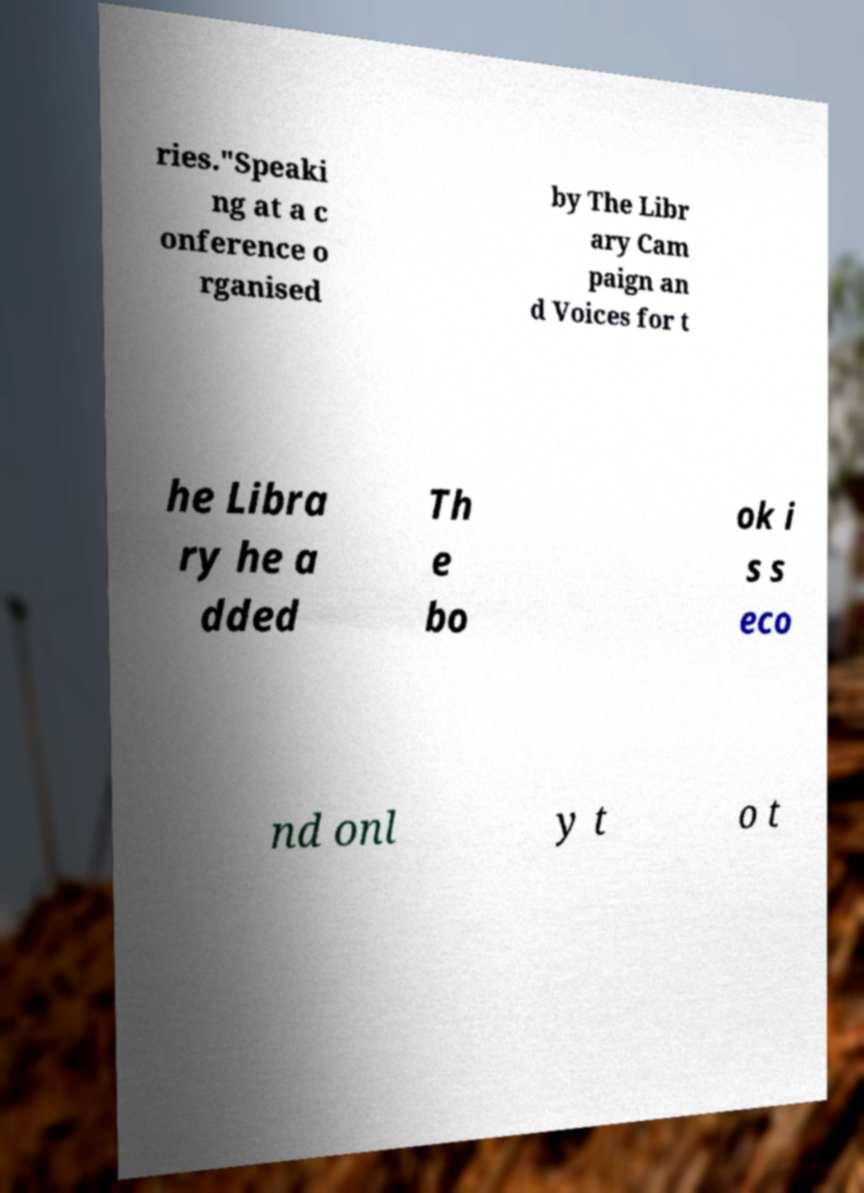Can you accurately transcribe the text from the provided image for me? ries."Speaki ng at a c onference o rganised by The Libr ary Cam paign an d Voices for t he Libra ry he a dded Th e bo ok i s s eco nd onl y t o t 